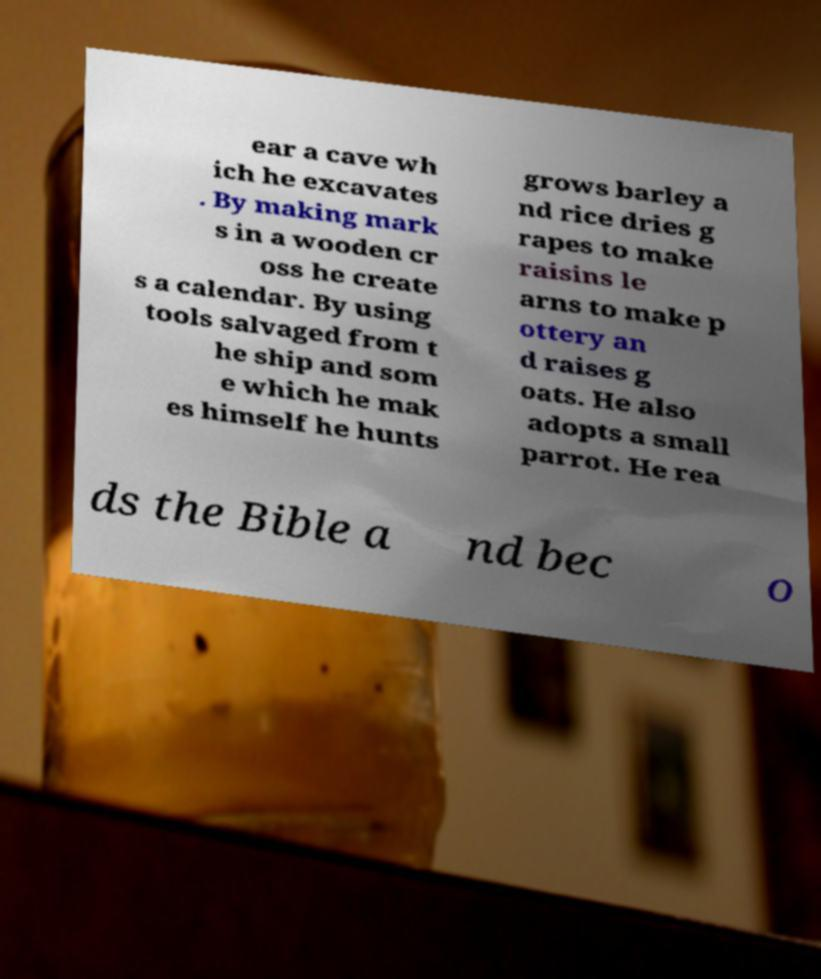Can you accurately transcribe the text from the provided image for me? ear a cave wh ich he excavates . By making mark s in a wooden cr oss he create s a calendar. By using tools salvaged from t he ship and som e which he mak es himself he hunts grows barley a nd rice dries g rapes to make raisins le arns to make p ottery an d raises g oats. He also adopts a small parrot. He rea ds the Bible a nd bec o 